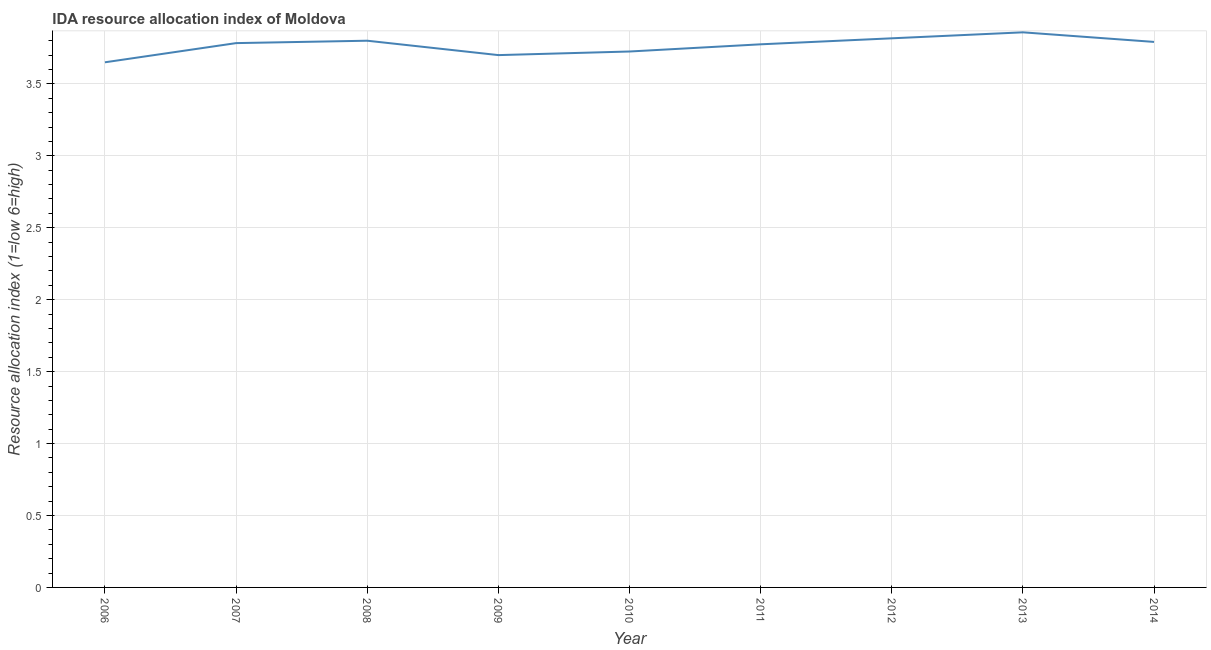What is the ida resource allocation index in 2010?
Your response must be concise. 3.73. Across all years, what is the maximum ida resource allocation index?
Ensure brevity in your answer.  3.86. Across all years, what is the minimum ida resource allocation index?
Your answer should be very brief. 3.65. In which year was the ida resource allocation index maximum?
Your answer should be compact. 2013. What is the sum of the ida resource allocation index?
Give a very brief answer. 33.9. What is the difference between the ida resource allocation index in 2007 and 2008?
Offer a terse response. -0.02. What is the average ida resource allocation index per year?
Offer a terse response. 3.77. What is the median ida resource allocation index?
Offer a terse response. 3.78. Do a majority of the years between 2010 and 2012 (inclusive) have ida resource allocation index greater than 0.2 ?
Provide a succinct answer. Yes. What is the ratio of the ida resource allocation index in 2012 to that in 2014?
Give a very brief answer. 1.01. Is the ida resource allocation index in 2010 less than that in 2012?
Keep it short and to the point. Yes. What is the difference between the highest and the second highest ida resource allocation index?
Your answer should be compact. 0.04. Is the sum of the ida resource allocation index in 2009 and 2010 greater than the maximum ida resource allocation index across all years?
Ensure brevity in your answer.  Yes. What is the difference between the highest and the lowest ida resource allocation index?
Give a very brief answer. 0.21. What is the difference between two consecutive major ticks on the Y-axis?
Ensure brevity in your answer.  0.5. What is the title of the graph?
Your answer should be compact. IDA resource allocation index of Moldova. What is the label or title of the Y-axis?
Provide a succinct answer. Resource allocation index (1=low 6=high). What is the Resource allocation index (1=low 6=high) of 2006?
Ensure brevity in your answer.  3.65. What is the Resource allocation index (1=low 6=high) of 2007?
Give a very brief answer. 3.78. What is the Resource allocation index (1=low 6=high) of 2008?
Give a very brief answer. 3.8. What is the Resource allocation index (1=low 6=high) of 2009?
Keep it short and to the point. 3.7. What is the Resource allocation index (1=low 6=high) in 2010?
Your answer should be very brief. 3.73. What is the Resource allocation index (1=low 6=high) in 2011?
Offer a terse response. 3.77. What is the Resource allocation index (1=low 6=high) in 2012?
Offer a terse response. 3.82. What is the Resource allocation index (1=low 6=high) of 2013?
Offer a very short reply. 3.86. What is the Resource allocation index (1=low 6=high) of 2014?
Your answer should be very brief. 3.79. What is the difference between the Resource allocation index (1=low 6=high) in 2006 and 2007?
Make the answer very short. -0.13. What is the difference between the Resource allocation index (1=low 6=high) in 2006 and 2010?
Give a very brief answer. -0.07. What is the difference between the Resource allocation index (1=low 6=high) in 2006 and 2011?
Your answer should be compact. -0.12. What is the difference between the Resource allocation index (1=low 6=high) in 2006 and 2012?
Keep it short and to the point. -0.17. What is the difference between the Resource allocation index (1=low 6=high) in 2006 and 2013?
Give a very brief answer. -0.21. What is the difference between the Resource allocation index (1=low 6=high) in 2006 and 2014?
Ensure brevity in your answer.  -0.14. What is the difference between the Resource allocation index (1=low 6=high) in 2007 and 2008?
Your answer should be compact. -0.02. What is the difference between the Resource allocation index (1=low 6=high) in 2007 and 2009?
Make the answer very short. 0.08. What is the difference between the Resource allocation index (1=low 6=high) in 2007 and 2010?
Offer a terse response. 0.06. What is the difference between the Resource allocation index (1=low 6=high) in 2007 and 2011?
Provide a short and direct response. 0.01. What is the difference between the Resource allocation index (1=low 6=high) in 2007 and 2012?
Offer a very short reply. -0.03. What is the difference between the Resource allocation index (1=low 6=high) in 2007 and 2013?
Provide a short and direct response. -0.07. What is the difference between the Resource allocation index (1=low 6=high) in 2007 and 2014?
Give a very brief answer. -0.01. What is the difference between the Resource allocation index (1=low 6=high) in 2008 and 2009?
Provide a succinct answer. 0.1. What is the difference between the Resource allocation index (1=low 6=high) in 2008 and 2010?
Make the answer very short. 0.07. What is the difference between the Resource allocation index (1=low 6=high) in 2008 and 2011?
Offer a very short reply. 0.03. What is the difference between the Resource allocation index (1=low 6=high) in 2008 and 2012?
Ensure brevity in your answer.  -0.02. What is the difference between the Resource allocation index (1=low 6=high) in 2008 and 2013?
Make the answer very short. -0.06. What is the difference between the Resource allocation index (1=low 6=high) in 2008 and 2014?
Your response must be concise. 0.01. What is the difference between the Resource allocation index (1=low 6=high) in 2009 and 2010?
Your answer should be very brief. -0.03. What is the difference between the Resource allocation index (1=low 6=high) in 2009 and 2011?
Keep it short and to the point. -0.07. What is the difference between the Resource allocation index (1=low 6=high) in 2009 and 2012?
Provide a succinct answer. -0.12. What is the difference between the Resource allocation index (1=low 6=high) in 2009 and 2013?
Your answer should be very brief. -0.16. What is the difference between the Resource allocation index (1=low 6=high) in 2009 and 2014?
Provide a succinct answer. -0.09. What is the difference between the Resource allocation index (1=low 6=high) in 2010 and 2012?
Your answer should be compact. -0.09. What is the difference between the Resource allocation index (1=low 6=high) in 2010 and 2013?
Ensure brevity in your answer.  -0.13. What is the difference between the Resource allocation index (1=low 6=high) in 2010 and 2014?
Provide a short and direct response. -0.07. What is the difference between the Resource allocation index (1=low 6=high) in 2011 and 2012?
Your answer should be compact. -0.04. What is the difference between the Resource allocation index (1=low 6=high) in 2011 and 2013?
Give a very brief answer. -0.08. What is the difference between the Resource allocation index (1=low 6=high) in 2011 and 2014?
Offer a very short reply. -0.02. What is the difference between the Resource allocation index (1=low 6=high) in 2012 and 2013?
Make the answer very short. -0.04. What is the difference between the Resource allocation index (1=low 6=high) in 2012 and 2014?
Your response must be concise. 0.03. What is the difference between the Resource allocation index (1=low 6=high) in 2013 and 2014?
Offer a very short reply. 0.07. What is the ratio of the Resource allocation index (1=low 6=high) in 2006 to that in 2011?
Your answer should be compact. 0.97. What is the ratio of the Resource allocation index (1=low 6=high) in 2006 to that in 2012?
Give a very brief answer. 0.96. What is the ratio of the Resource allocation index (1=low 6=high) in 2006 to that in 2013?
Offer a terse response. 0.95. What is the ratio of the Resource allocation index (1=low 6=high) in 2007 to that in 2008?
Offer a terse response. 1. What is the ratio of the Resource allocation index (1=low 6=high) in 2007 to that in 2011?
Ensure brevity in your answer.  1. What is the ratio of the Resource allocation index (1=low 6=high) in 2007 to that in 2013?
Make the answer very short. 0.98. What is the ratio of the Resource allocation index (1=low 6=high) in 2008 to that in 2014?
Provide a succinct answer. 1. What is the ratio of the Resource allocation index (1=low 6=high) in 2009 to that in 2013?
Give a very brief answer. 0.96. What is the ratio of the Resource allocation index (1=low 6=high) in 2009 to that in 2014?
Offer a terse response. 0.98. What is the ratio of the Resource allocation index (1=low 6=high) in 2010 to that in 2011?
Give a very brief answer. 0.99. What is the ratio of the Resource allocation index (1=low 6=high) in 2010 to that in 2012?
Make the answer very short. 0.98. What is the ratio of the Resource allocation index (1=low 6=high) in 2011 to that in 2013?
Keep it short and to the point. 0.98. What is the ratio of the Resource allocation index (1=low 6=high) in 2012 to that in 2013?
Offer a very short reply. 0.99. What is the ratio of the Resource allocation index (1=low 6=high) in 2012 to that in 2014?
Provide a succinct answer. 1.01. 